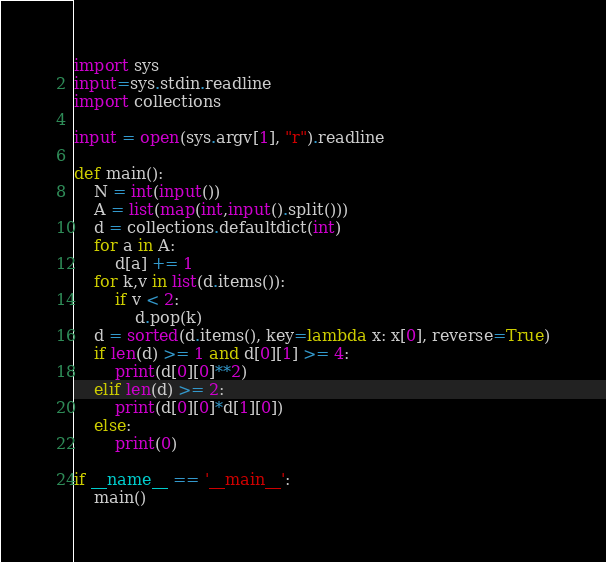Convert code to text. <code><loc_0><loc_0><loc_500><loc_500><_Python_>import sys
input=sys.stdin.readline
import collections

input = open(sys.argv[1], "r").readline

def main():
    N = int(input())
    A = list(map(int,input().split()))
    d = collections.defaultdict(int)
    for a in A:
        d[a] += 1
    for k,v in list(d.items()):
        if v < 2:
            d.pop(k)
    d = sorted(d.items(), key=lambda x: x[0], reverse=True)
    if len(d) >= 1 and d[0][1] >= 4:
        print(d[0][0]**2)
    elif len(d) >= 2:
        print(d[0][0]*d[1][0])
    else:
        print(0)

if __name__ == '__main__':
    main()
</code> 